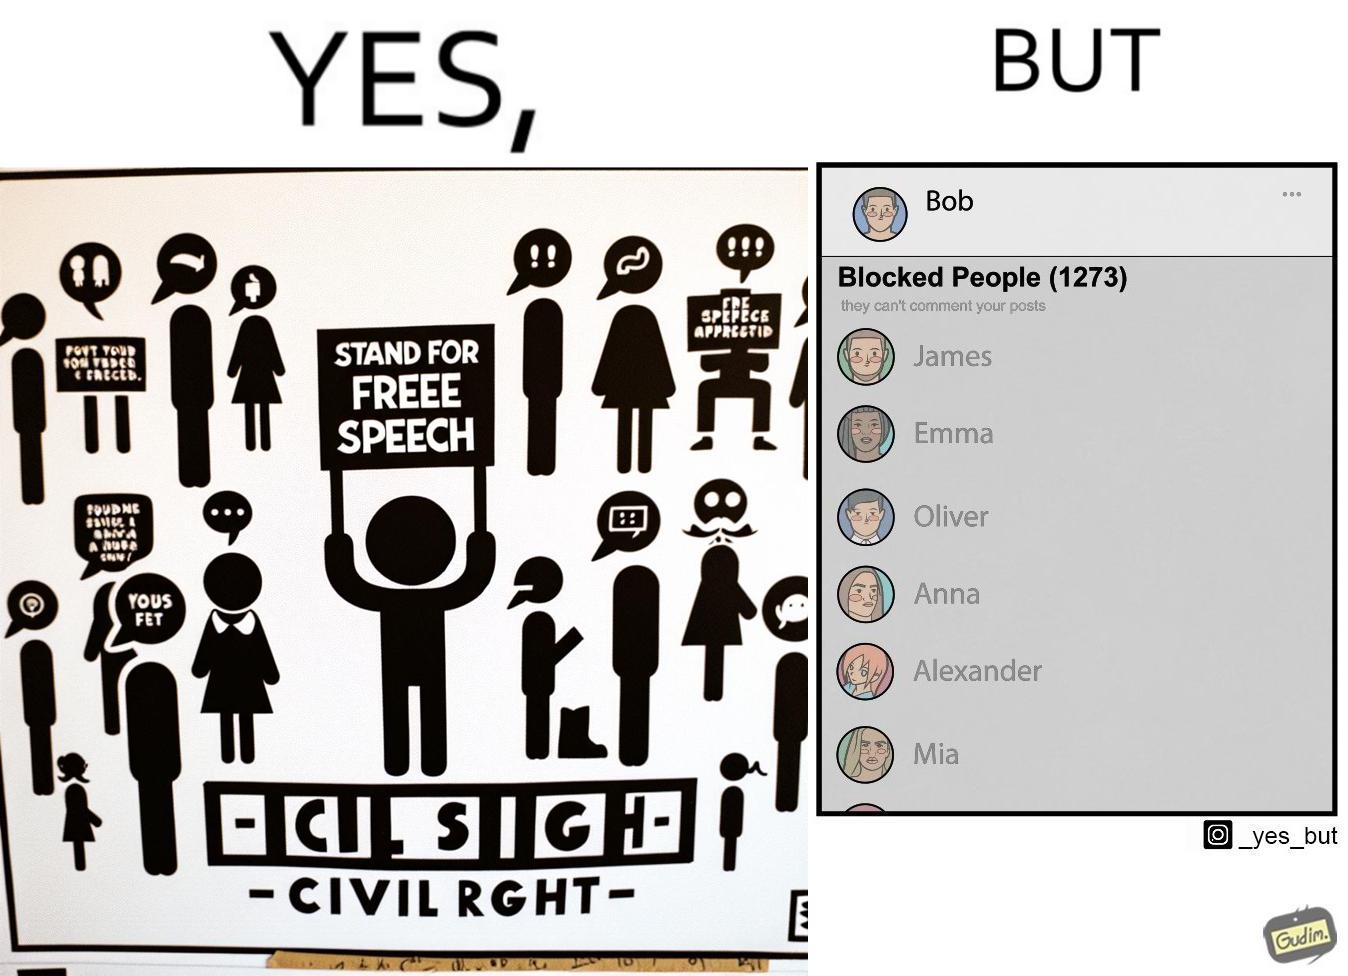Describe the contrast between the left and right parts of this image. In the left part of the image: It is a social media post by "Bob" showing his support for free speech as a civil right In the right part of the image: It is a list of all the prople "Bob" has blocked on his contacts list 